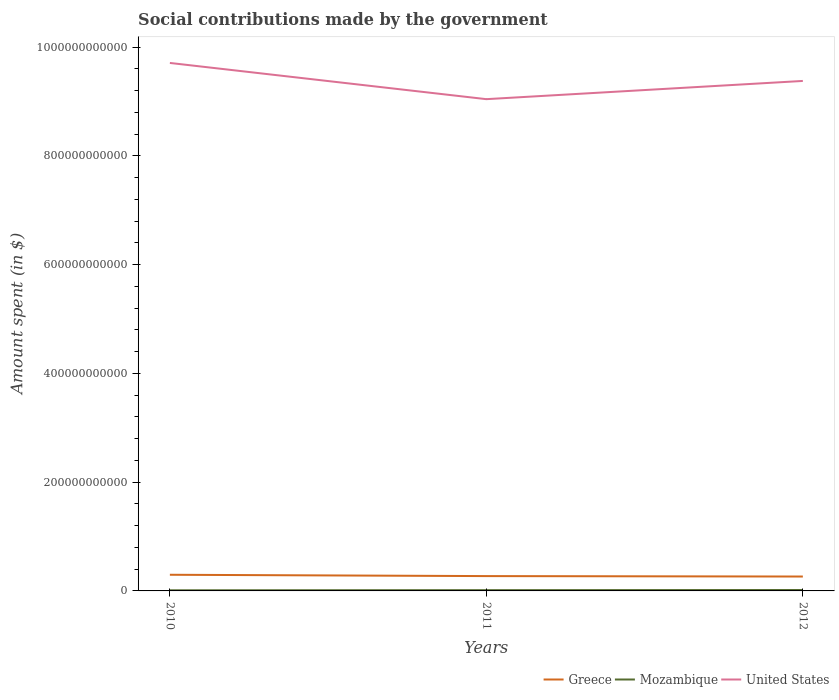How many different coloured lines are there?
Make the answer very short. 3. Does the line corresponding to Mozambique intersect with the line corresponding to United States?
Ensure brevity in your answer.  No. Is the number of lines equal to the number of legend labels?
Keep it short and to the point. Yes. Across all years, what is the maximum amount spent on social contributions in United States?
Offer a very short reply. 9.04e+11. In which year was the amount spent on social contributions in Mozambique maximum?
Keep it short and to the point. 2010. What is the total amount spent on social contributions in United States in the graph?
Your response must be concise. 3.31e+1. What is the difference between the highest and the second highest amount spent on social contributions in Mozambique?
Your answer should be very brief. 5.26e+08. What is the difference between the highest and the lowest amount spent on social contributions in Greece?
Your answer should be very brief. 1. How many lines are there?
Your answer should be compact. 3. How many years are there in the graph?
Your answer should be very brief. 3. What is the difference between two consecutive major ticks on the Y-axis?
Offer a terse response. 2.00e+11. Are the values on the major ticks of Y-axis written in scientific E-notation?
Your answer should be very brief. No. Does the graph contain any zero values?
Your answer should be very brief. No. How are the legend labels stacked?
Ensure brevity in your answer.  Horizontal. What is the title of the graph?
Ensure brevity in your answer.  Social contributions made by the government. Does "Thailand" appear as one of the legend labels in the graph?
Your response must be concise. No. What is the label or title of the X-axis?
Offer a terse response. Years. What is the label or title of the Y-axis?
Make the answer very short. Amount spent (in $). What is the Amount spent (in $) in Greece in 2010?
Your answer should be compact. 2.97e+1. What is the Amount spent (in $) in Mozambique in 2010?
Offer a terse response. 1.16e+09. What is the Amount spent (in $) in United States in 2010?
Provide a succinct answer. 9.71e+11. What is the Amount spent (in $) of Greece in 2011?
Provide a succinct answer. 2.73e+1. What is the Amount spent (in $) of Mozambique in 2011?
Provide a short and direct response. 1.42e+09. What is the Amount spent (in $) of United States in 2011?
Give a very brief answer. 9.04e+11. What is the Amount spent (in $) of Greece in 2012?
Keep it short and to the point. 2.65e+1. What is the Amount spent (in $) in Mozambique in 2012?
Keep it short and to the point. 1.69e+09. What is the Amount spent (in $) of United States in 2012?
Your response must be concise. 9.38e+11. Across all years, what is the maximum Amount spent (in $) of Greece?
Make the answer very short. 2.97e+1. Across all years, what is the maximum Amount spent (in $) in Mozambique?
Make the answer very short. 1.69e+09. Across all years, what is the maximum Amount spent (in $) of United States?
Keep it short and to the point. 9.71e+11. Across all years, what is the minimum Amount spent (in $) in Greece?
Provide a succinct answer. 2.65e+1. Across all years, what is the minimum Amount spent (in $) in Mozambique?
Your answer should be compact. 1.16e+09. Across all years, what is the minimum Amount spent (in $) in United States?
Keep it short and to the point. 9.04e+11. What is the total Amount spent (in $) of Greece in the graph?
Provide a short and direct response. 8.34e+1. What is the total Amount spent (in $) of Mozambique in the graph?
Provide a succinct answer. 4.27e+09. What is the total Amount spent (in $) of United States in the graph?
Keep it short and to the point. 2.81e+12. What is the difference between the Amount spent (in $) of Greece in 2010 and that in 2011?
Give a very brief answer. 2.43e+09. What is the difference between the Amount spent (in $) of Mozambique in 2010 and that in 2011?
Your answer should be compact. -2.60e+08. What is the difference between the Amount spent (in $) in United States in 2010 and that in 2011?
Offer a very short reply. 6.66e+1. What is the difference between the Amount spent (in $) of Greece in 2010 and that in 2012?
Your answer should be very brief. 3.23e+09. What is the difference between the Amount spent (in $) of Mozambique in 2010 and that in 2012?
Make the answer very short. -5.26e+08. What is the difference between the Amount spent (in $) of United States in 2010 and that in 2012?
Provide a short and direct response. 3.31e+1. What is the difference between the Amount spent (in $) of Greece in 2011 and that in 2012?
Provide a short and direct response. 7.97e+08. What is the difference between the Amount spent (in $) of Mozambique in 2011 and that in 2012?
Keep it short and to the point. -2.67e+08. What is the difference between the Amount spent (in $) of United States in 2011 and that in 2012?
Make the answer very short. -3.35e+1. What is the difference between the Amount spent (in $) of Greece in 2010 and the Amount spent (in $) of Mozambique in 2011?
Provide a succinct answer. 2.83e+1. What is the difference between the Amount spent (in $) of Greece in 2010 and the Amount spent (in $) of United States in 2011?
Give a very brief answer. -8.75e+11. What is the difference between the Amount spent (in $) in Mozambique in 2010 and the Amount spent (in $) in United States in 2011?
Ensure brevity in your answer.  -9.03e+11. What is the difference between the Amount spent (in $) in Greece in 2010 and the Amount spent (in $) in Mozambique in 2012?
Offer a very short reply. 2.80e+1. What is the difference between the Amount spent (in $) of Greece in 2010 and the Amount spent (in $) of United States in 2012?
Your answer should be compact. -9.08e+11. What is the difference between the Amount spent (in $) of Mozambique in 2010 and the Amount spent (in $) of United States in 2012?
Give a very brief answer. -9.37e+11. What is the difference between the Amount spent (in $) in Greece in 2011 and the Amount spent (in $) in Mozambique in 2012?
Keep it short and to the point. 2.56e+1. What is the difference between the Amount spent (in $) of Greece in 2011 and the Amount spent (in $) of United States in 2012?
Your answer should be very brief. -9.11e+11. What is the difference between the Amount spent (in $) of Mozambique in 2011 and the Amount spent (in $) of United States in 2012?
Your response must be concise. -9.36e+11. What is the average Amount spent (in $) of Greece per year?
Provide a short and direct response. 2.78e+1. What is the average Amount spent (in $) of Mozambique per year?
Keep it short and to the point. 1.42e+09. What is the average Amount spent (in $) of United States per year?
Your response must be concise. 9.38e+11. In the year 2010, what is the difference between the Amount spent (in $) in Greece and Amount spent (in $) in Mozambique?
Your answer should be compact. 2.85e+1. In the year 2010, what is the difference between the Amount spent (in $) in Greece and Amount spent (in $) in United States?
Provide a short and direct response. -9.41e+11. In the year 2010, what is the difference between the Amount spent (in $) in Mozambique and Amount spent (in $) in United States?
Your answer should be very brief. -9.70e+11. In the year 2011, what is the difference between the Amount spent (in $) of Greece and Amount spent (in $) of Mozambique?
Keep it short and to the point. 2.59e+1. In the year 2011, what is the difference between the Amount spent (in $) in Greece and Amount spent (in $) in United States?
Your answer should be compact. -8.77e+11. In the year 2011, what is the difference between the Amount spent (in $) in Mozambique and Amount spent (in $) in United States?
Offer a very short reply. -9.03e+11. In the year 2012, what is the difference between the Amount spent (in $) of Greece and Amount spent (in $) of Mozambique?
Make the answer very short. 2.48e+1. In the year 2012, what is the difference between the Amount spent (in $) of Greece and Amount spent (in $) of United States?
Offer a very short reply. -9.11e+11. In the year 2012, what is the difference between the Amount spent (in $) in Mozambique and Amount spent (in $) in United States?
Give a very brief answer. -9.36e+11. What is the ratio of the Amount spent (in $) of Greece in 2010 to that in 2011?
Make the answer very short. 1.09. What is the ratio of the Amount spent (in $) in Mozambique in 2010 to that in 2011?
Provide a short and direct response. 0.82. What is the ratio of the Amount spent (in $) in United States in 2010 to that in 2011?
Keep it short and to the point. 1.07. What is the ratio of the Amount spent (in $) of Greece in 2010 to that in 2012?
Make the answer very short. 1.12. What is the ratio of the Amount spent (in $) in Mozambique in 2010 to that in 2012?
Your response must be concise. 0.69. What is the ratio of the Amount spent (in $) in United States in 2010 to that in 2012?
Offer a terse response. 1.04. What is the ratio of the Amount spent (in $) in Greece in 2011 to that in 2012?
Give a very brief answer. 1.03. What is the ratio of the Amount spent (in $) in Mozambique in 2011 to that in 2012?
Make the answer very short. 0.84. What is the difference between the highest and the second highest Amount spent (in $) of Greece?
Give a very brief answer. 2.43e+09. What is the difference between the highest and the second highest Amount spent (in $) of Mozambique?
Ensure brevity in your answer.  2.67e+08. What is the difference between the highest and the second highest Amount spent (in $) of United States?
Your answer should be very brief. 3.31e+1. What is the difference between the highest and the lowest Amount spent (in $) in Greece?
Offer a terse response. 3.23e+09. What is the difference between the highest and the lowest Amount spent (in $) in Mozambique?
Make the answer very short. 5.26e+08. What is the difference between the highest and the lowest Amount spent (in $) of United States?
Ensure brevity in your answer.  6.66e+1. 